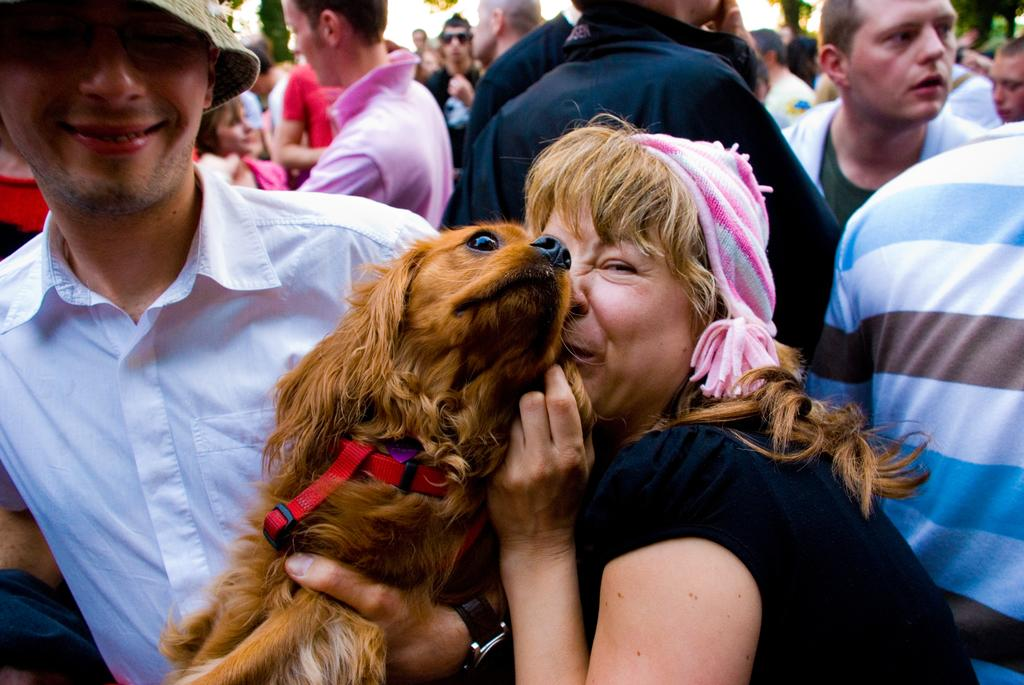What is the main subject of the image? The main subject of the image is a group of people. What are two persons in the group doing? Two persons in the group are holding a dog. Can you describe the attire of one of the people in the image? At least one person in the image is wearing a cap. What emotion is being expressed by one of the people in the image? There is a person smiling in the image. What type of stitch is being used to sew the sheet in the image? There is no sheet or stitching present in the image; it features a group of people with a dog. 